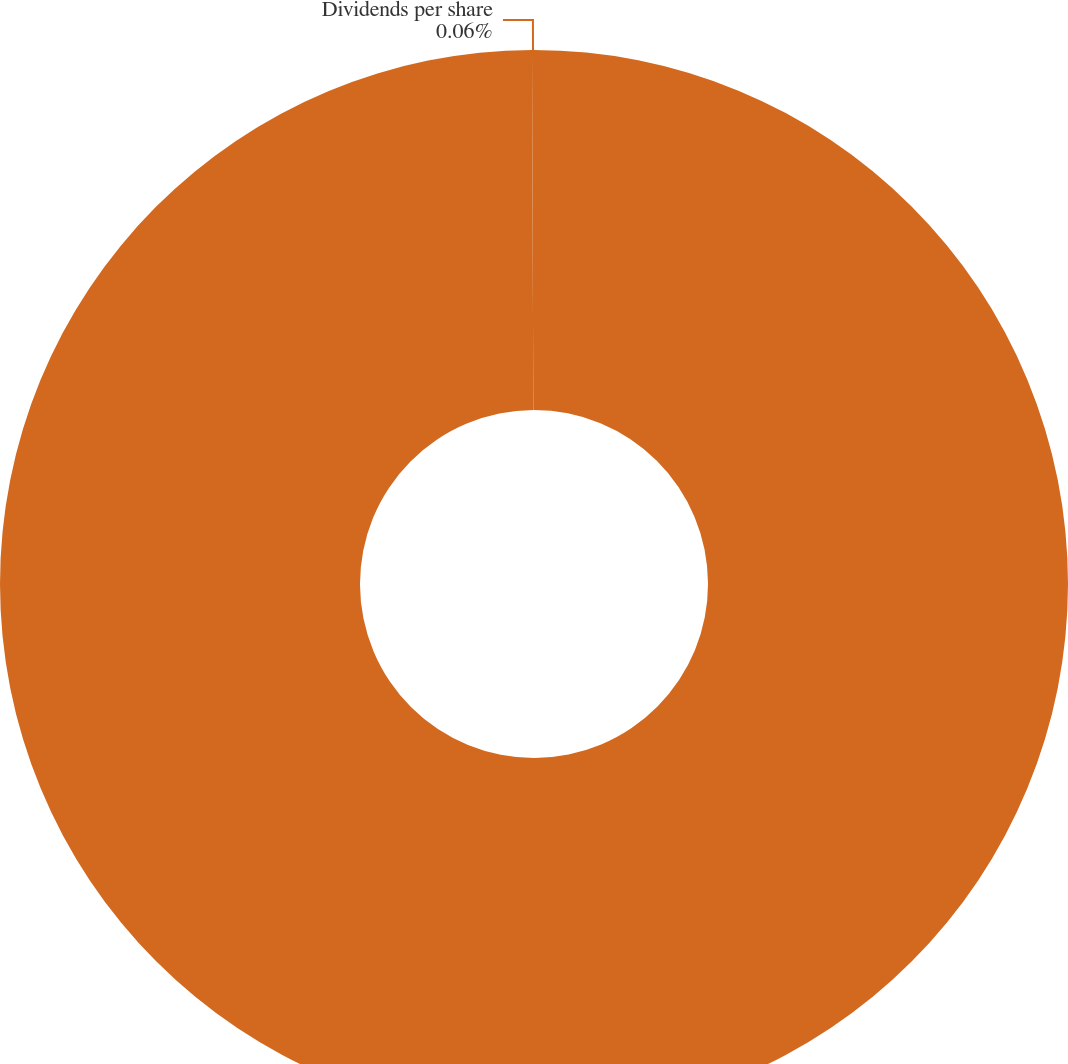<chart> <loc_0><loc_0><loc_500><loc_500><pie_chart><fcel>(in dollars split-adjusted)<fcel>Dividends per share<nl><fcel>99.94%<fcel>0.06%<nl></chart> 